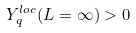<formula> <loc_0><loc_0><loc_500><loc_500>Y _ { q } ^ { l o c } ( L = \infty ) > 0</formula> 